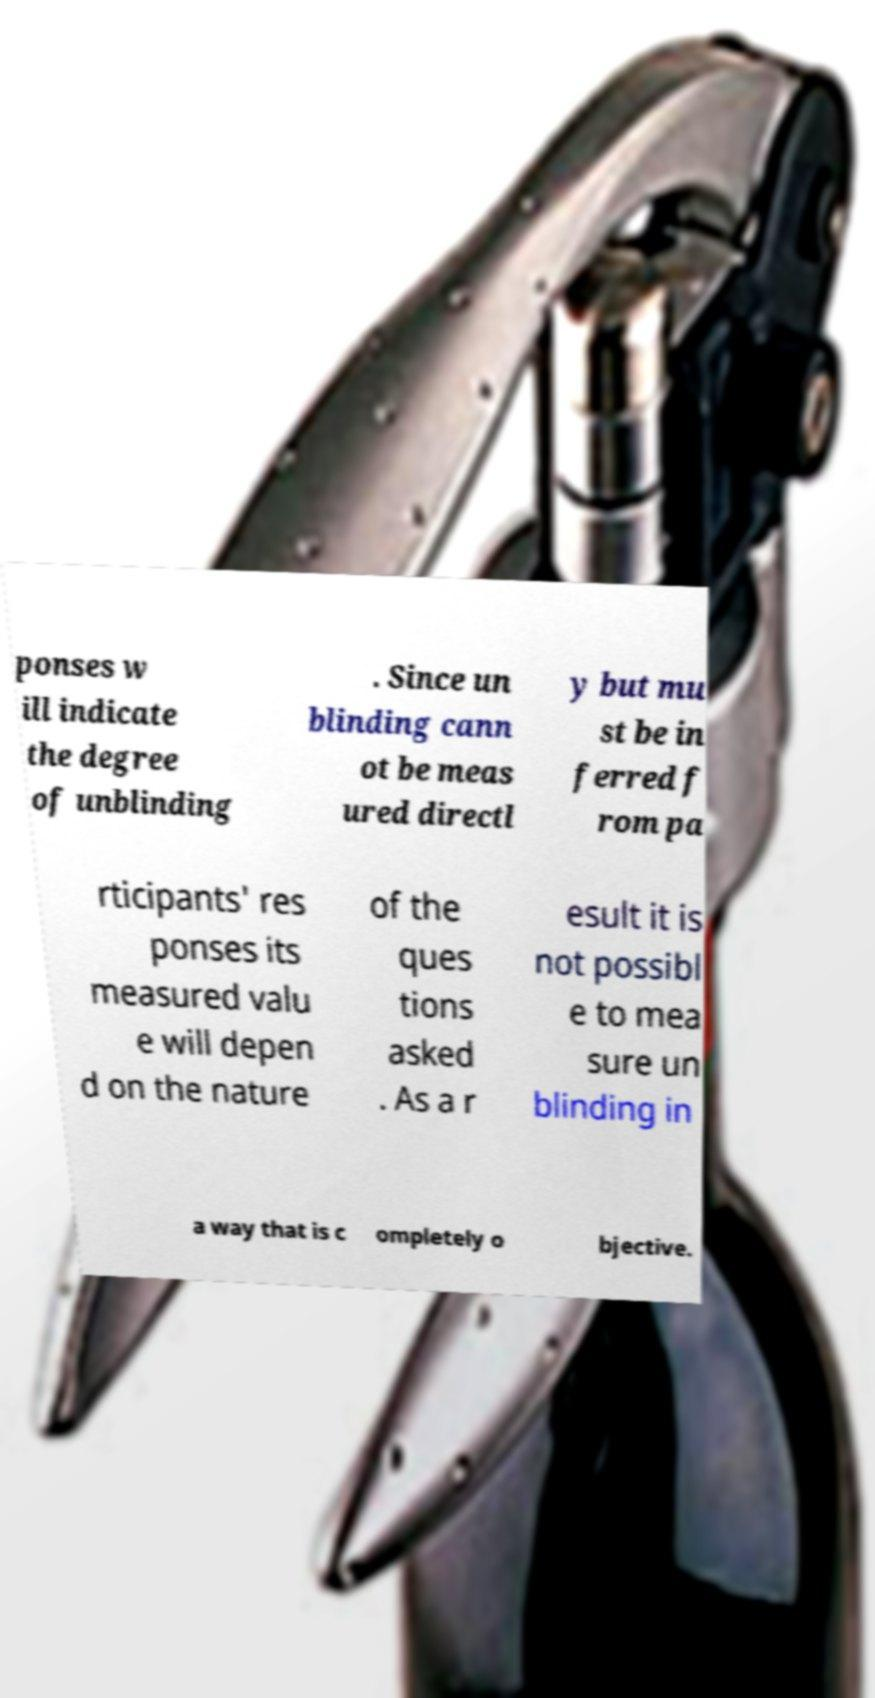For documentation purposes, I need the text within this image transcribed. Could you provide that? ponses w ill indicate the degree of unblinding . Since un blinding cann ot be meas ured directl y but mu st be in ferred f rom pa rticipants' res ponses its measured valu e will depen d on the nature of the ques tions asked . As a r esult it is not possibl e to mea sure un blinding in a way that is c ompletely o bjective. 